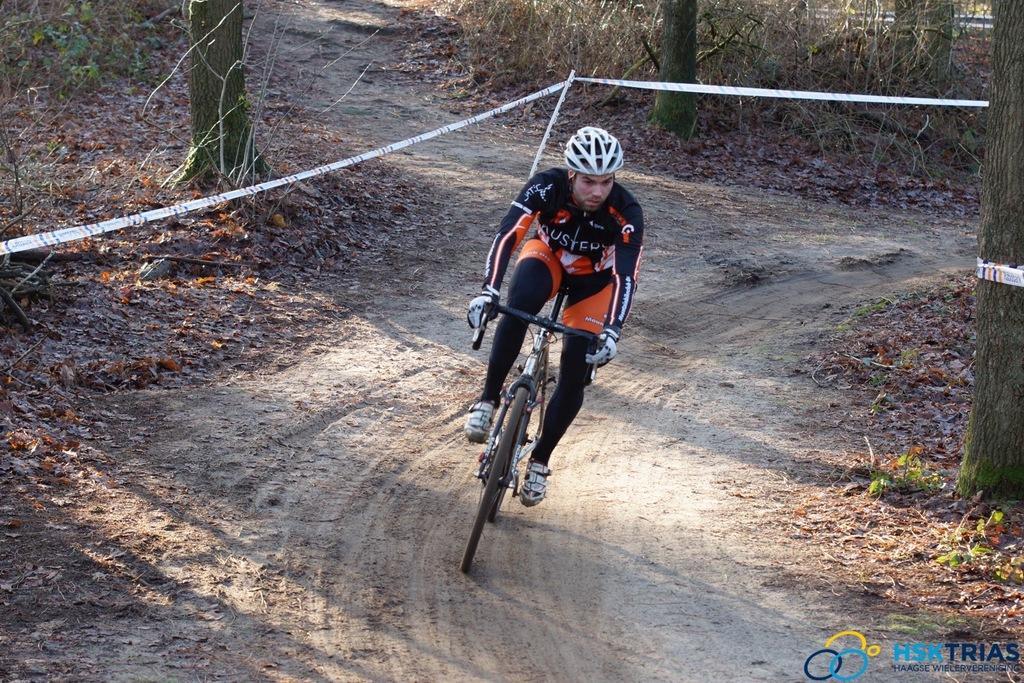Can you describe this image briefly? In this image we can see person riding bicycle and wearing a helmet. In the background we can see trees, plants, shredded leaves and ground. 